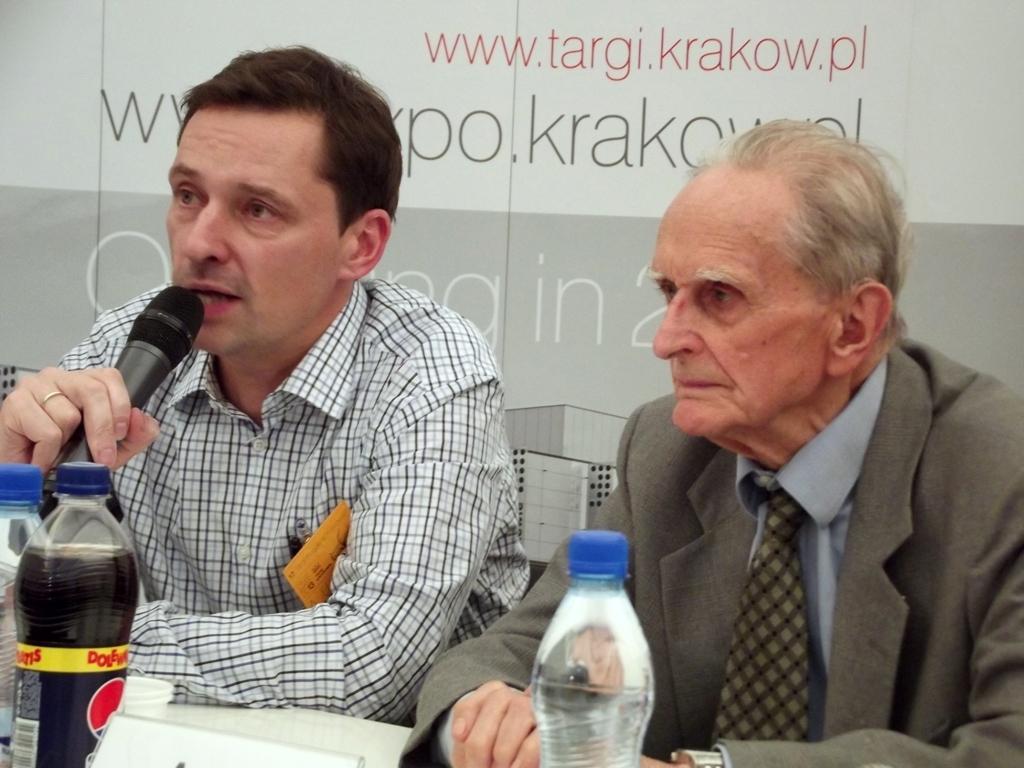Can you describe this image briefly? In this image there are two men sitting besides a table. The person towards the left, he is wearing check shirt and speaking on a mike. The person towards the right he is wearing blazers and tie and he is staring. There are two bottles in the left and one bottle in the center. In the background there is a wall and some text printed on it. 